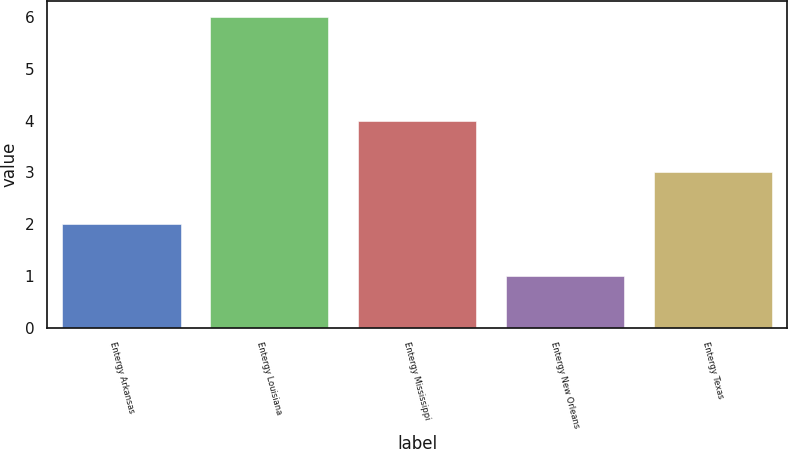Convert chart to OTSL. <chart><loc_0><loc_0><loc_500><loc_500><bar_chart><fcel>Entergy Arkansas<fcel>Entergy Louisiana<fcel>Entergy Mississippi<fcel>Entergy New Orleans<fcel>Entergy Texas<nl><fcel>2<fcel>6<fcel>4<fcel>1<fcel>3<nl></chart> 